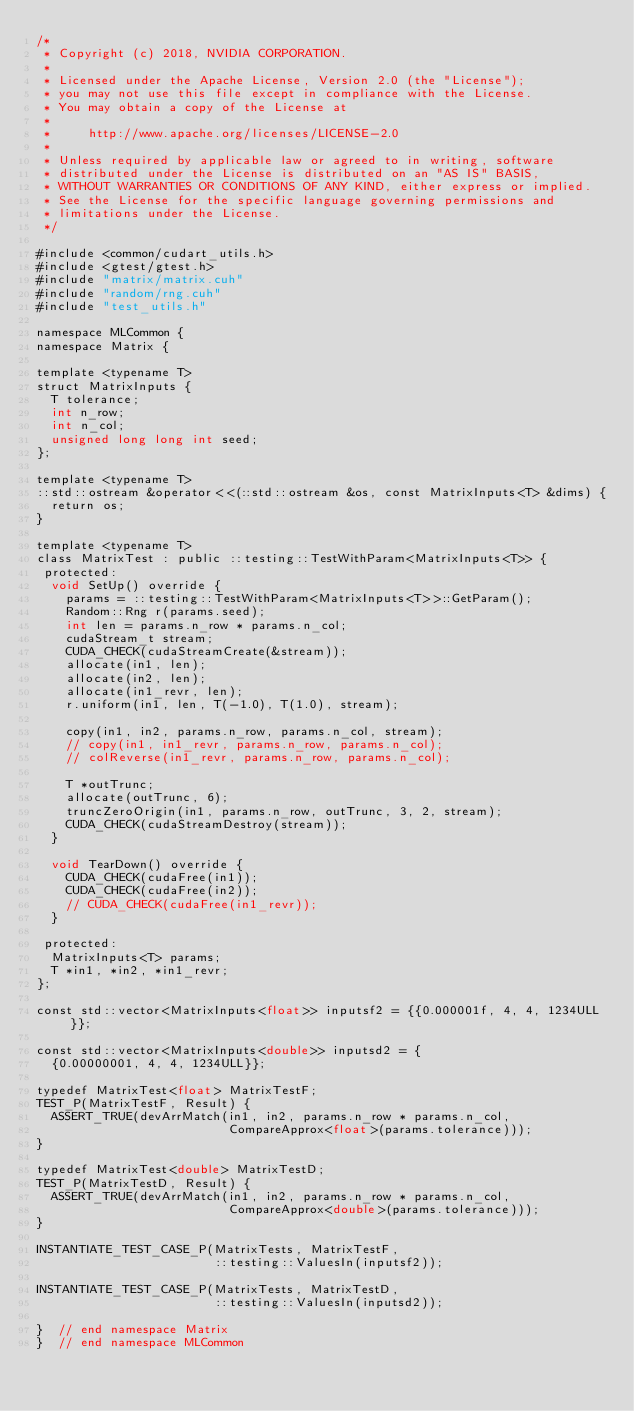<code> <loc_0><loc_0><loc_500><loc_500><_Cuda_>/*
 * Copyright (c) 2018, NVIDIA CORPORATION.
 *
 * Licensed under the Apache License, Version 2.0 (the "License");
 * you may not use this file except in compliance with the License.
 * You may obtain a copy of the License at
 *
 *     http://www.apache.org/licenses/LICENSE-2.0
 *
 * Unless required by applicable law or agreed to in writing, software
 * distributed under the License is distributed on an "AS IS" BASIS,
 * WITHOUT WARRANTIES OR CONDITIONS OF ANY KIND, either express or implied.
 * See the License for the specific language governing permissions and
 * limitations under the License.
 */

#include <common/cudart_utils.h>
#include <gtest/gtest.h>
#include "matrix/matrix.cuh"
#include "random/rng.cuh"
#include "test_utils.h"

namespace MLCommon {
namespace Matrix {

template <typename T>
struct MatrixInputs {
  T tolerance;
  int n_row;
  int n_col;
  unsigned long long int seed;
};

template <typename T>
::std::ostream &operator<<(::std::ostream &os, const MatrixInputs<T> &dims) {
  return os;
}

template <typename T>
class MatrixTest : public ::testing::TestWithParam<MatrixInputs<T>> {
 protected:
  void SetUp() override {
    params = ::testing::TestWithParam<MatrixInputs<T>>::GetParam();
    Random::Rng r(params.seed);
    int len = params.n_row * params.n_col;
    cudaStream_t stream;
    CUDA_CHECK(cudaStreamCreate(&stream));
    allocate(in1, len);
    allocate(in2, len);
    allocate(in1_revr, len);
    r.uniform(in1, len, T(-1.0), T(1.0), stream);

    copy(in1, in2, params.n_row, params.n_col, stream);
    // copy(in1, in1_revr, params.n_row, params.n_col);
    // colReverse(in1_revr, params.n_row, params.n_col);

    T *outTrunc;
    allocate(outTrunc, 6);
    truncZeroOrigin(in1, params.n_row, outTrunc, 3, 2, stream);
    CUDA_CHECK(cudaStreamDestroy(stream));
  }

  void TearDown() override {
    CUDA_CHECK(cudaFree(in1));
    CUDA_CHECK(cudaFree(in2));
    // CUDA_CHECK(cudaFree(in1_revr));
  }

 protected:
  MatrixInputs<T> params;
  T *in1, *in2, *in1_revr;
};

const std::vector<MatrixInputs<float>> inputsf2 = {{0.000001f, 4, 4, 1234ULL}};

const std::vector<MatrixInputs<double>> inputsd2 = {
  {0.00000001, 4, 4, 1234ULL}};

typedef MatrixTest<float> MatrixTestF;
TEST_P(MatrixTestF, Result) {
  ASSERT_TRUE(devArrMatch(in1, in2, params.n_row * params.n_col,
                          CompareApprox<float>(params.tolerance)));
}

typedef MatrixTest<double> MatrixTestD;
TEST_P(MatrixTestD, Result) {
  ASSERT_TRUE(devArrMatch(in1, in2, params.n_row * params.n_col,
                          CompareApprox<double>(params.tolerance)));
}

INSTANTIATE_TEST_CASE_P(MatrixTests, MatrixTestF,
                        ::testing::ValuesIn(inputsf2));

INSTANTIATE_TEST_CASE_P(MatrixTests, MatrixTestD,
                        ::testing::ValuesIn(inputsd2));

}  // end namespace Matrix
}  // end namespace MLCommon
</code> 